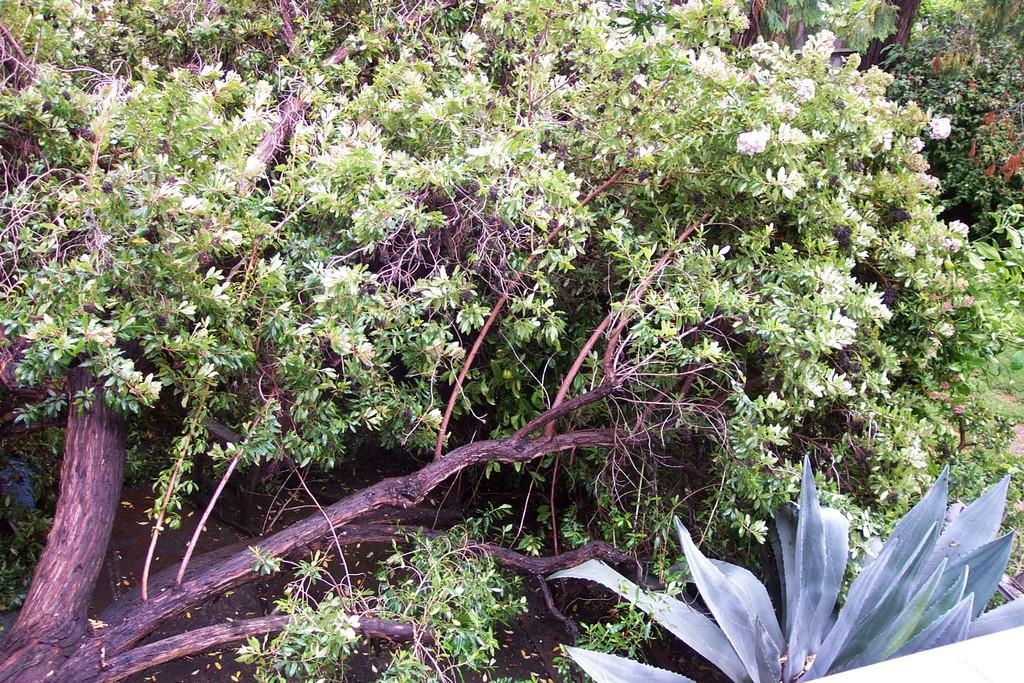Describe this image in one or two sentences. In this image we can see trees and plants. 